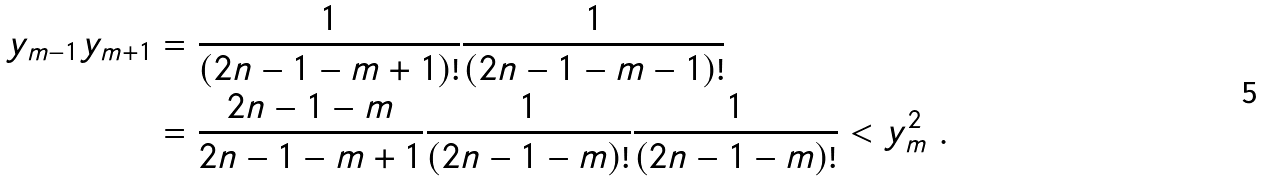<formula> <loc_0><loc_0><loc_500><loc_500>y _ { m - 1 } y _ { m + 1 } & = \frac { 1 } { ( 2 n - 1 - m + 1 ) ! } \frac { 1 } { ( 2 n - 1 - m - 1 ) ! } \\ & = \frac { 2 n - 1 - m } { 2 n - 1 - m + 1 } \frac { 1 } { ( 2 n - 1 - m ) ! } \frac { 1 } { ( 2 n - 1 - m ) ! } < y _ { m } ^ { 2 } \ .</formula> 